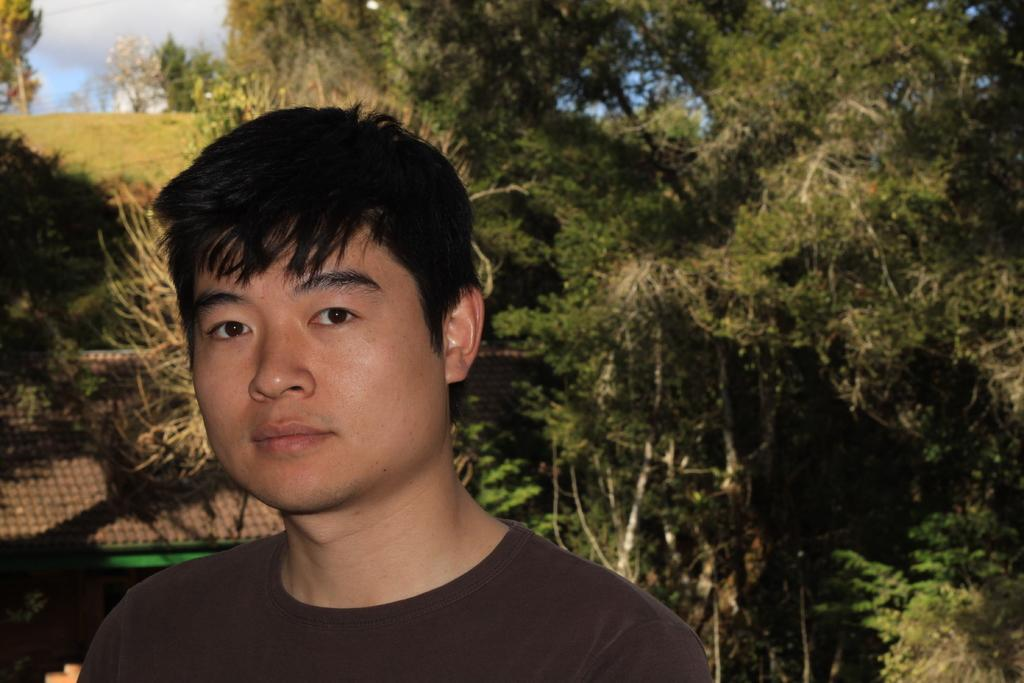Who is present in the image? There is a man in the image. What can be seen in the background of the image? There are trees, plants, a house, grass, a hill, and the sky visible in the background of the image. What type of oven can be seen in the image? There is no oven present in the image. Can you describe the man's teaching method in the image? There is no indication of teaching or any educational activity in the image. 